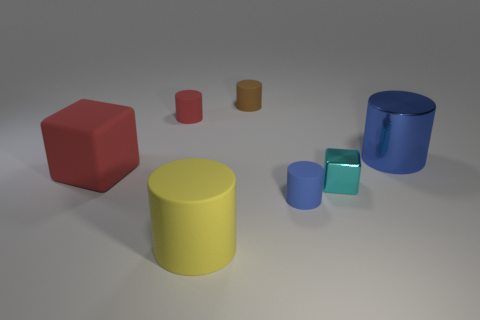Can you tell me the arrangement of objects based on their sizes? From largest to smallest, the objects are: the blue cylindrical container, the yellow cylinder, the large red block, the green cylinder, the smaller green cylinder, the red cube, and lastly the tiny red cylinder. Which object is at the center of the image? The yellow cylinder is centrally located in the image. 